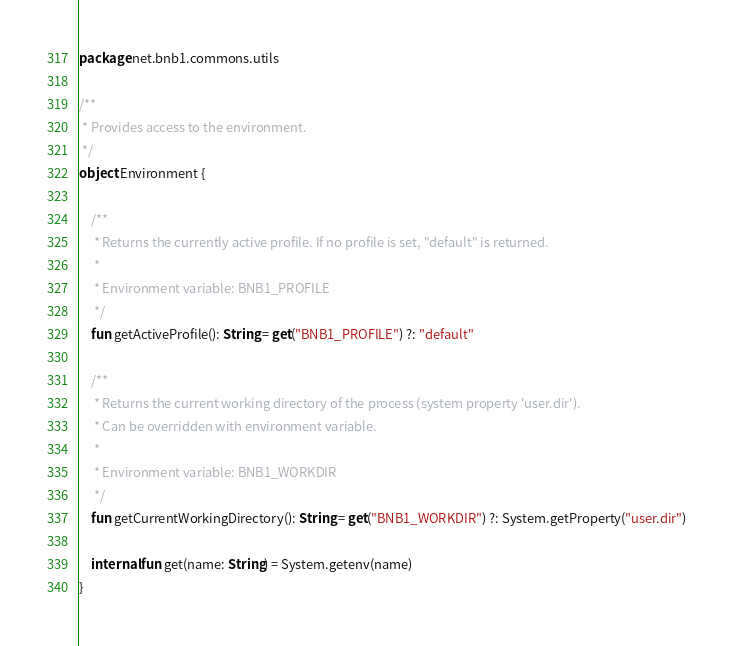<code> <loc_0><loc_0><loc_500><loc_500><_Kotlin_>package net.bnb1.commons.utils

/**
 * Provides access to the environment.
 */
object Environment {

    /**
     * Returns the currently active profile. If no profile is set, "default" is returned.
     *
     * Environment variable: BNB1_PROFILE
     */
    fun getActiveProfile(): String = get("BNB1_PROFILE") ?: "default"

    /**
     * Returns the current working directory of the process (system property 'user.dir').
     * Can be overridden with environment variable.
     *
     * Environment variable: BNB1_WORKDIR
     */
    fun getCurrentWorkingDirectory(): String = get("BNB1_WORKDIR") ?: System.getProperty("user.dir")

    internal fun get(name: String) = System.getenv(name)
}
</code> 